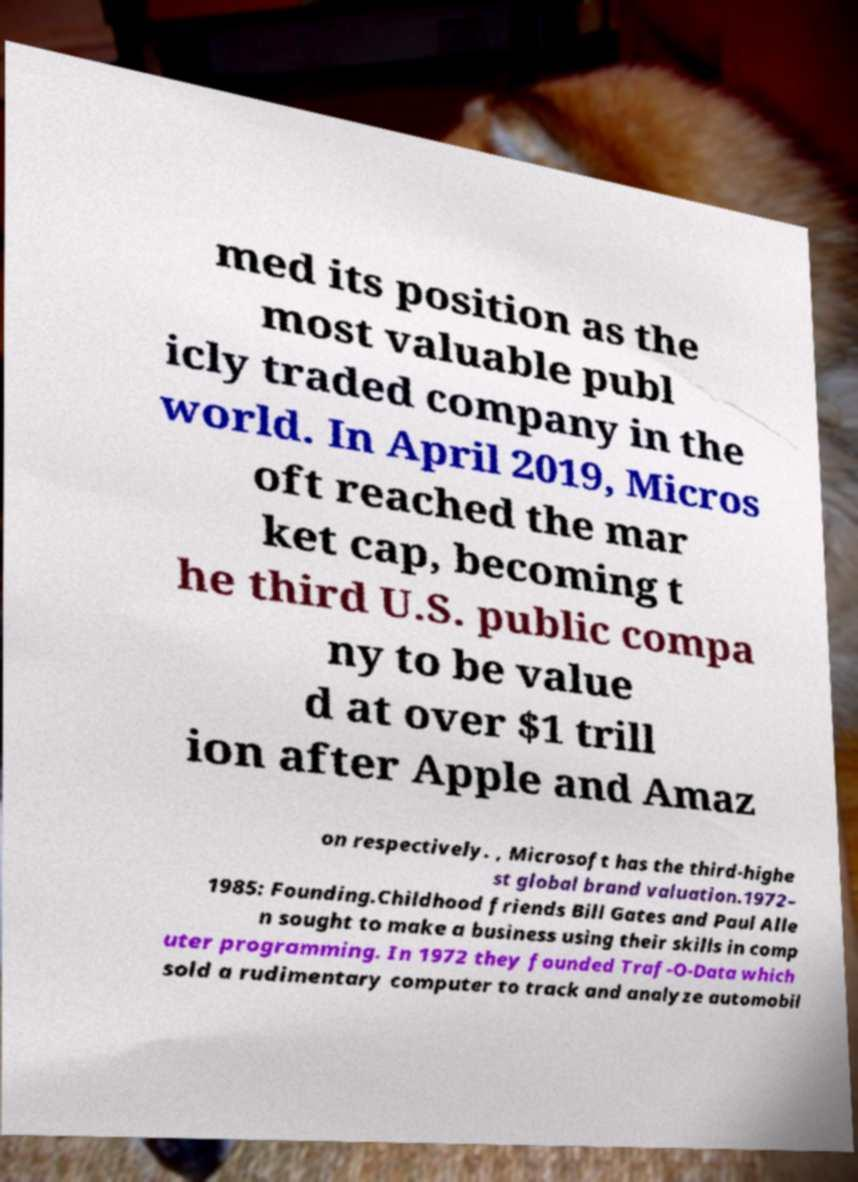What messages or text are displayed in this image? I need them in a readable, typed format. med its position as the most valuable publ icly traded company in the world. In April 2019, Micros oft reached the mar ket cap, becoming t he third U.S. public compa ny to be value d at over $1 trill ion after Apple and Amaz on respectively. , Microsoft has the third-highe st global brand valuation.1972– 1985: Founding.Childhood friends Bill Gates and Paul Alle n sought to make a business using their skills in comp uter programming. In 1972 they founded Traf-O-Data which sold a rudimentary computer to track and analyze automobil 